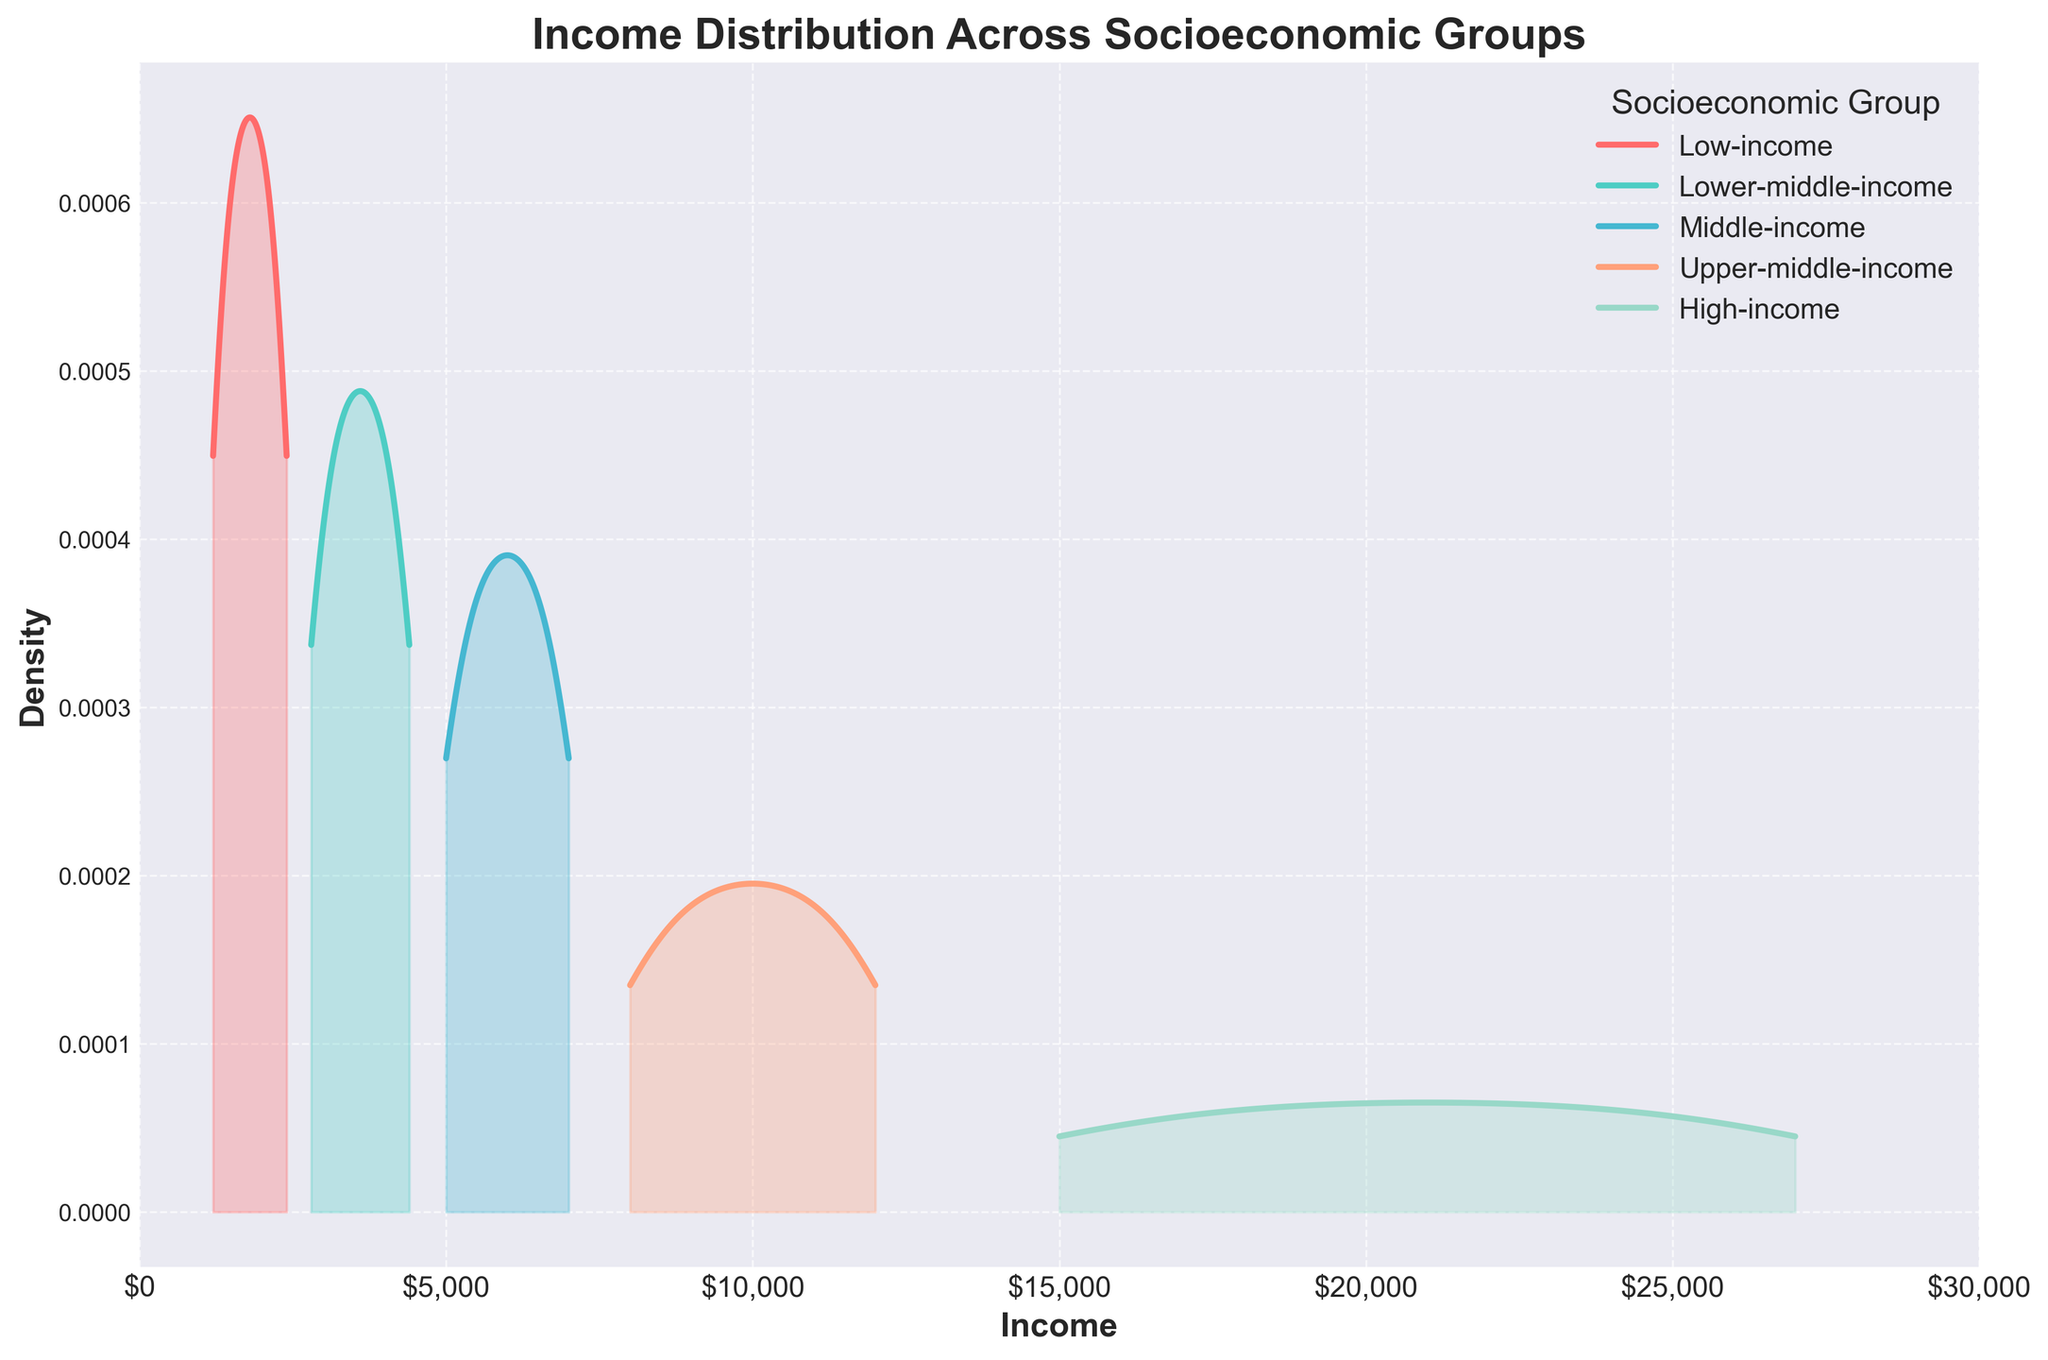How many socioeconomic groups are represented in the plot? The legend of the plot shows the different socioeconomic groups represented. The figure indicates five different groups: Low-income, Lower-middle-income, Middle-income, Upper-middle-income, and High-income.
Answer: 5 Which socioeconomic group has the highest peak density in the plot? By observing the height of the density curves, it's apparent which one has the highest peak. The Low-income group's density curve has the highest peak among all the groups.
Answer: Low-income What is the approximate income range for the Middle-income group in the plot? Check the x-axis range where the Middle-income group's density is non-zero. The Middle-income density starts around $5,000 and ends around $7,000.
Answer: $5,000 to $7,000 Which socioeconomic group's income density is distributed across the largest range? Look at the width of the curves on the x-axis. The High-income group's density covers the broadest range, as it spans from $15,000 to $27,000.
Answer: High-income Where is the density peak for the Upper-middle-income group located? Locate the highest point in the density curve of the Upper-middle-income group on the x-axis. The peak for the Upper-middle-income group is around $10,000.
Answer: $10,000 Which group has the most concentrated income density distribution? The concentration refers to the density spread over a narrow range. The Low-income group has the most concentrated density since its peak is very sharp.
Answer: Low-income Do any socioeconomic groups have overlapping income ranges? If so, which ones? Compare the x-axis ranges of the density curves for overlap. The Lower-middle-income group and the Middle-income group have overlapping ranges, between $4,000 and $6,000.
Answer: Lower-middle-income and Middle-income What can you infer about the income distribution of the High-income group based on its density curve? A wider, flatter distribution indicates greater dispersion. The High-income group's density is spread out and relatively flat, implying that incomes vary widely within this group.
Answer: High income varies widely How does the income distribution of the Lower-middle-income group compare to the Middle-income group in terms of peak density? Observe the peaks of both curves. The peak density of the Lower-middle-income group is lower compared to the Middle-income group, indicating that the latter is more concentrated around a specific income level.
Answer: Middle-income is more concentrated What is the color representation of the Upper-middle-income group in the plot? The legend in the plot shows the color associated with each group. The Upper-middle-income group is represented by a light orange color.
Answer: Light orange 